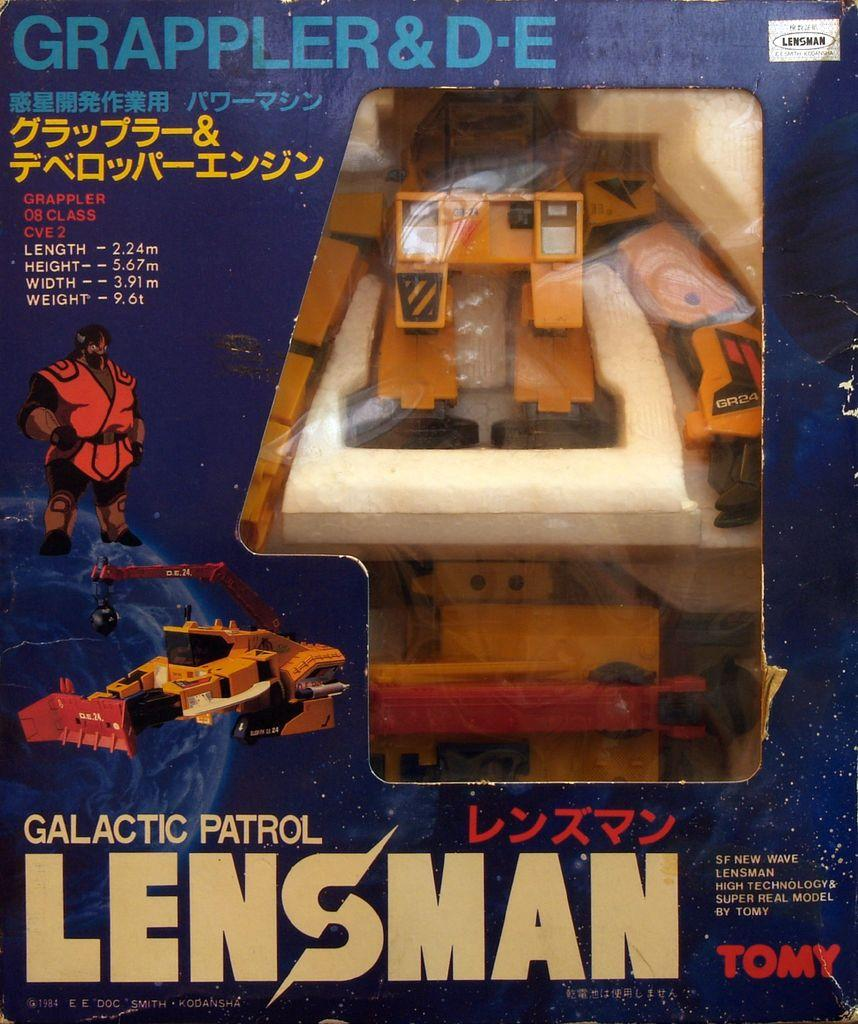<image>
Relay a brief, clear account of the picture shown. A toy called the Galactic Patrol Lensman is in a box. 